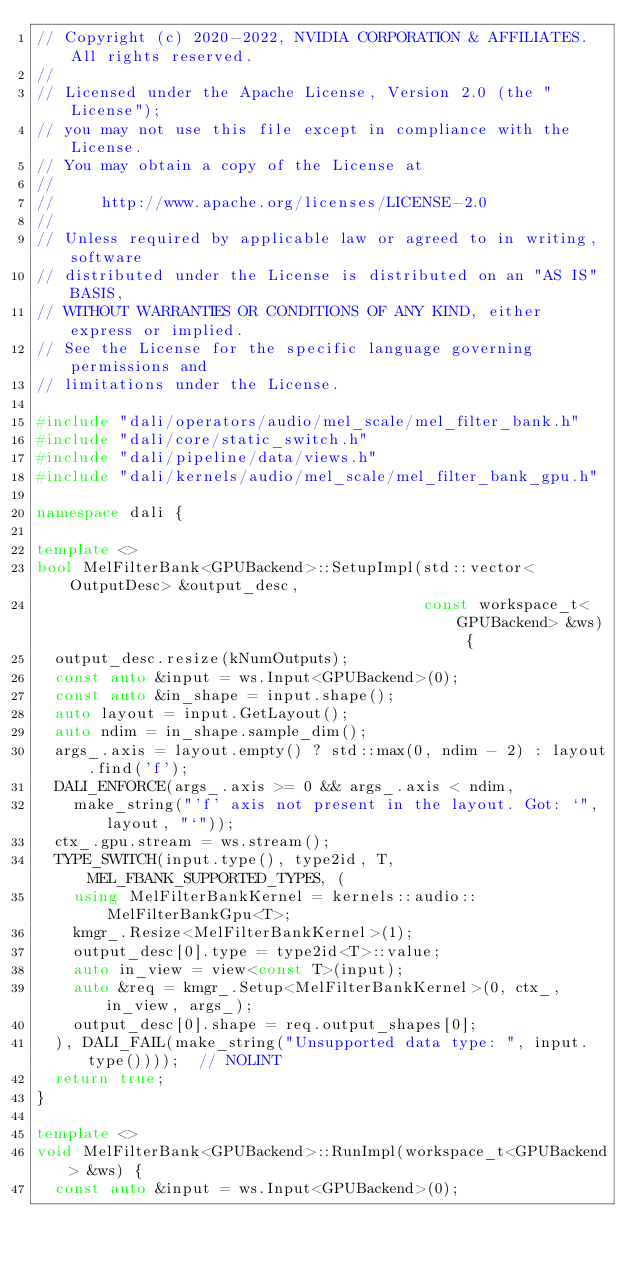<code> <loc_0><loc_0><loc_500><loc_500><_C++_>// Copyright (c) 2020-2022, NVIDIA CORPORATION & AFFILIATES. All rights reserved.
//
// Licensed under the Apache License, Version 2.0 (the "License");
// you may not use this file except in compliance with the License.
// You may obtain a copy of the License at
//
//     http://www.apache.org/licenses/LICENSE-2.0
//
// Unless required by applicable law or agreed to in writing, software
// distributed under the License is distributed on an "AS IS" BASIS,
// WITHOUT WARRANTIES OR CONDITIONS OF ANY KIND, either express or implied.
// See the License for the specific language governing permissions and
// limitations under the License.

#include "dali/operators/audio/mel_scale/mel_filter_bank.h"
#include "dali/core/static_switch.h"
#include "dali/pipeline/data/views.h"
#include "dali/kernels/audio/mel_scale/mel_filter_bank_gpu.h"

namespace dali {

template <>
bool MelFilterBank<GPUBackend>::SetupImpl(std::vector<OutputDesc> &output_desc,
                                          const workspace_t<GPUBackend> &ws) {
  output_desc.resize(kNumOutputs);
  const auto &input = ws.Input<GPUBackend>(0);
  const auto &in_shape = input.shape();
  auto layout = input.GetLayout();
  auto ndim = in_shape.sample_dim();
  args_.axis = layout.empty() ? std::max(0, ndim - 2) : layout.find('f');
  DALI_ENFORCE(args_.axis >= 0 && args_.axis < ndim,
    make_string("'f' axis not present in the layout. Got: `", layout, "`"));
  ctx_.gpu.stream = ws.stream();
  TYPE_SWITCH(input.type(), type2id, T, MEL_FBANK_SUPPORTED_TYPES, (
    using MelFilterBankKernel = kernels::audio::MelFilterBankGpu<T>;
    kmgr_.Resize<MelFilterBankKernel>(1);
    output_desc[0].type = type2id<T>::value;
    auto in_view = view<const T>(input);
    auto &req = kmgr_.Setup<MelFilterBankKernel>(0, ctx_, in_view, args_);
    output_desc[0].shape = req.output_shapes[0];
  ), DALI_FAIL(make_string("Unsupported data type: ", input.type())));  // NOLINT
  return true;
}

template <>
void MelFilterBank<GPUBackend>::RunImpl(workspace_t<GPUBackend> &ws) {
  const auto &input = ws.Input<GPUBackend>(0);</code> 